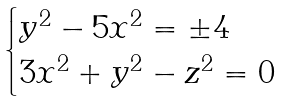<formula> <loc_0><loc_0><loc_500><loc_500>\begin{cases} y ^ { 2 } - 5 x ^ { 2 } = \pm 4 \\ 3 x ^ { 2 } + y ^ { 2 } - z ^ { 2 } = 0 \end{cases}</formula> 